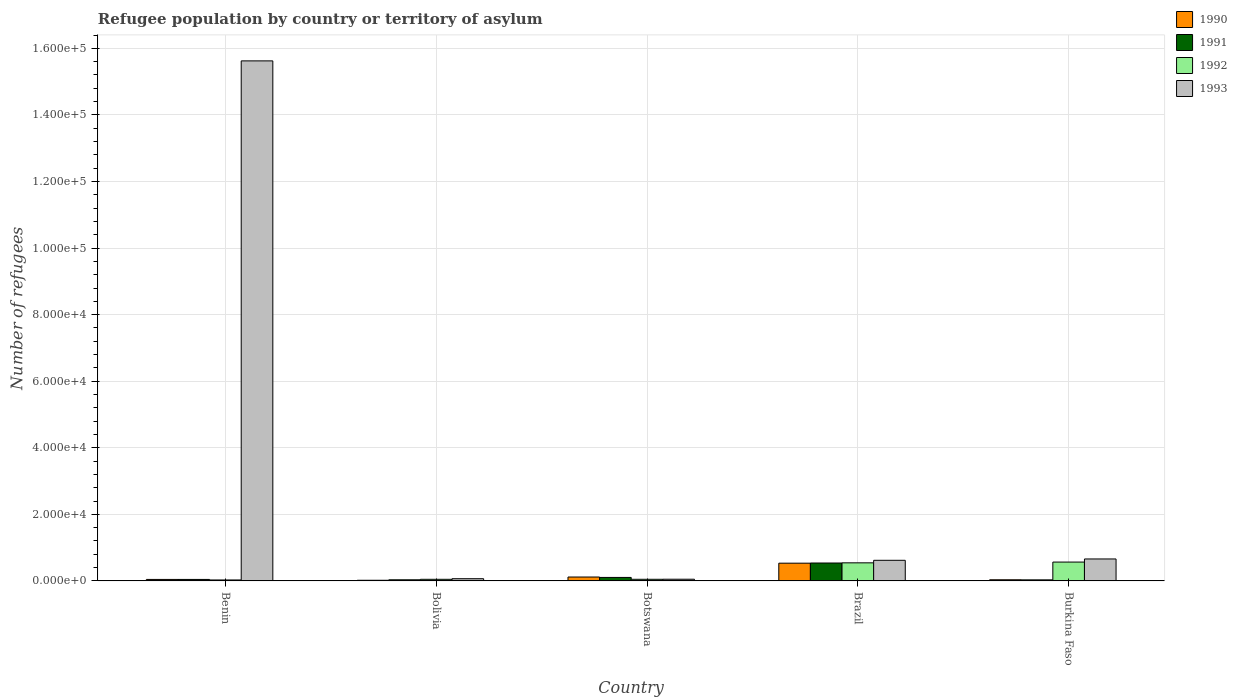How many bars are there on the 4th tick from the left?
Give a very brief answer. 4. How many bars are there on the 3rd tick from the right?
Offer a very short reply. 4. What is the label of the 4th group of bars from the left?
Ensure brevity in your answer.  Brazil. What is the number of refugees in 1992 in Bolivia?
Provide a short and direct response. 491. Across all countries, what is the maximum number of refugees in 1992?
Keep it short and to the point. 5670. In which country was the number of refugees in 1993 maximum?
Your response must be concise. Benin. What is the total number of refugees in 1991 in the graph?
Provide a succinct answer. 7560. What is the difference between the number of refugees in 1992 in Bolivia and that in Burkina Faso?
Your answer should be compact. -5179. What is the difference between the number of refugees in 1993 in Burkina Faso and the number of refugees in 1991 in Brazil?
Ensure brevity in your answer.  1215. What is the average number of refugees in 1990 per country?
Keep it short and to the point. 1504. What is the difference between the number of refugees of/in 1990 and number of refugees of/in 1992 in Botswana?
Offer a terse response. 682. In how many countries, is the number of refugees in 1993 greater than 104000?
Offer a terse response. 1. What is the ratio of the number of refugees in 1992 in Bolivia to that in Burkina Faso?
Provide a succinct answer. 0.09. Is the difference between the number of refugees in 1990 in Benin and Brazil greater than the difference between the number of refugees in 1992 in Benin and Brazil?
Offer a very short reply. Yes. What is the difference between the highest and the second highest number of refugees in 1991?
Ensure brevity in your answer.  -4933. What is the difference between the highest and the lowest number of refugees in 1992?
Give a very brief answer. 5377. In how many countries, is the number of refugees in 1993 greater than the average number of refugees in 1993 taken over all countries?
Ensure brevity in your answer.  1. Is the sum of the number of refugees in 1991 in Benin and Brazil greater than the maximum number of refugees in 1992 across all countries?
Offer a very short reply. Yes. Is it the case that in every country, the sum of the number of refugees in 1993 and number of refugees in 1992 is greater than the sum of number of refugees in 1990 and number of refugees in 1991?
Offer a terse response. No. What does the 2nd bar from the left in Botswana represents?
Give a very brief answer. 1991. Is it the case that in every country, the sum of the number of refugees in 1991 and number of refugees in 1992 is greater than the number of refugees in 1993?
Your answer should be compact. No. How many bars are there?
Give a very brief answer. 20. Are all the bars in the graph horizontal?
Make the answer very short. No. What is the difference between two consecutive major ticks on the Y-axis?
Your answer should be compact. 2.00e+04. Does the graph contain grids?
Ensure brevity in your answer.  Yes. Where does the legend appear in the graph?
Your answer should be compact. Top right. How are the legend labels stacked?
Your answer should be compact. Vertical. What is the title of the graph?
Ensure brevity in your answer.  Refugee population by country or territory of asylum. What is the label or title of the Y-axis?
Provide a succinct answer. Number of refugees. What is the Number of refugees of 1990 in Benin?
Your answer should be very brief. 456. What is the Number of refugees in 1991 in Benin?
Keep it short and to the point. 456. What is the Number of refugees in 1992 in Benin?
Make the answer very short. 293. What is the Number of refugees of 1993 in Benin?
Make the answer very short. 1.56e+05. What is the Number of refugees of 1990 in Bolivia?
Make the answer very short. 200. What is the Number of refugees in 1991 in Bolivia?
Your answer should be very brief. 341. What is the Number of refugees in 1992 in Bolivia?
Keep it short and to the point. 491. What is the Number of refugees of 1993 in Bolivia?
Your answer should be very brief. 669. What is the Number of refugees in 1990 in Botswana?
Offer a terse response. 1179. What is the Number of refugees of 1991 in Botswana?
Offer a very short reply. 1054. What is the Number of refugees in 1992 in Botswana?
Your answer should be compact. 497. What is the Number of refugees in 1993 in Botswana?
Your answer should be compact. 514. What is the Number of refugees in 1990 in Brazil?
Offer a very short reply. 5335. What is the Number of refugees of 1991 in Brazil?
Provide a short and direct response. 5389. What is the Number of refugees in 1992 in Brazil?
Your answer should be compact. 5439. What is the Number of refugees of 1993 in Brazil?
Your answer should be very brief. 6198. What is the Number of refugees of 1990 in Burkina Faso?
Give a very brief answer. 350. What is the Number of refugees of 1991 in Burkina Faso?
Give a very brief answer. 320. What is the Number of refugees in 1992 in Burkina Faso?
Your response must be concise. 5670. What is the Number of refugees of 1993 in Burkina Faso?
Your answer should be compact. 6604. Across all countries, what is the maximum Number of refugees in 1990?
Your answer should be very brief. 5335. Across all countries, what is the maximum Number of refugees of 1991?
Your answer should be very brief. 5389. Across all countries, what is the maximum Number of refugees of 1992?
Offer a terse response. 5670. Across all countries, what is the maximum Number of refugees of 1993?
Your response must be concise. 1.56e+05. Across all countries, what is the minimum Number of refugees in 1991?
Your answer should be very brief. 320. Across all countries, what is the minimum Number of refugees in 1992?
Make the answer very short. 293. Across all countries, what is the minimum Number of refugees of 1993?
Give a very brief answer. 514. What is the total Number of refugees of 1990 in the graph?
Give a very brief answer. 7520. What is the total Number of refugees of 1991 in the graph?
Your response must be concise. 7560. What is the total Number of refugees in 1992 in the graph?
Offer a very short reply. 1.24e+04. What is the total Number of refugees of 1993 in the graph?
Give a very brief answer. 1.70e+05. What is the difference between the Number of refugees of 1990 in Benin and that in Bolivia?
Your answer should be very brief. 256. What is the difference between the Number of refugees of 1991 in Benin and that in Bolivia?
Offer a very short reply. 115. What is the difference between the Number of refugees in 1992 in Benin and that in Bolivia?
Your answer should be very brief. -198. What is the difference between the Number of refugees of 1993 in Benin and that in Bolivia?
Ensure brevity in your answer.  1.56e+05. What is the difference between the Number of refugees of 1990 in Benin and that in Botswana?
Your response must be concise. -723. What is the difference between the Number of refugees of 1991 in Benin and that in Botswana?
Your answer should be very brief. -598. What is the difference between the Number of refugees in 1992 in Benin and that in Botswana?
Keep it short and to the point. -204. What is the difference between the Number of refugees in 1993 in Benin and that in Botswana?
Keep it short and to the point. 1.56e+05. What is the difference between the Number of refugees of 1990 in Benin and that in Brazil?
Your answer should be very brief. -4879. What is the difference between the Number of refugees of 1991 in Benin and that in Brazil?
Make the answer very short. -4933. What is the difference between the Number of refugees in 1992 in Benin and that in Brazil?
Provide a short and direct response. -5146. What is the difference between the Number of refugees of 1993 in Benin and that in Brazil?
Your answer should be compact. 1.50e+05. What is the difference between the Number of refugees in 1990 in Benin and that in Burkina Faso?
Provide a short and direct response. 106. What is the difference between the Number of refugees of 1991 in Benin and that in Burkina Faso?
Your response must be concise. 136. What is the difference between the Number of refugees of 1992 in Benin and that in Burkina Faso?
Ensure brevity in your answer.  -5377. What is the difference between the Number of refugees of 1993 in Benin and that in Burkina Faso?
Your response must be concise. 1.50e+05. What is the difference between the Number of refugees of 1990 in Bolivia and that in Botswana?
Keep it short and to the point. -979. What is the difference between the Number of refugees of 1991 in Bolivia and that in Botswana?
Your answer should be compact. -713. What is the difference between the Number of refugees in 1992 in Bolivia and that in Botswana?
Make the answer very short. -6. What is the difference between the Number of refugees of 1993 in Bolivia and that in Botswana?
Offer a very short reply. 155. What is the difference between the Number of refugees in 1990 in Bolivia and that in Brazil?
Offer a very short reply. -5135. What is the difference between the Number of refugees of 1991 in Bolivia and that in Brazil?
Ensure brevity in your answer.  -5048. What is the difference between the Number of refugees of 1992 in Bolivia and that in Brazil?
Your response must be concise. -4948. What is the difference between the Number of refugees of 1993 in Bolivia and that in Brazil?
Offer a terse response. -5529. What is the difference between the Number of refugees of 1990 in Bolivia and that in Burkina Faso?
Give a very brief answer. -150. What is the difference between the Number of refugees in 1991 in Bolivia and that in Burkina Faso?
Keep it short and to the point. 21. What is the difference between the Number of refugees of 1992 in Bolivia and that in Burkina Faso?
Your answer should be compact. -5179. What is the difference between the Number of refugees of 1993 in Bolivia and that in Burkina Faso?
Offer a very short reply. -5935. What is the difference between the Number of refugees in 1990 in Botswana and that in Brazil?
Keep it short and to the point. -4156. What is the difference between the Number of refugees of 1991 in Botswana and that in Brazil?
Your answer should be compact. -4335. What is the difference between the Number of refugees of 1992 in Botswana and that in Brazil?
Offer a very short reply. -4942. What is the difference between the Number of refugees in 1993 in Botswana and that in Brazil?
Your answer should be very brief. -5684. What is the difference between the Number of refugees of 1990 in Botswana and that in Burkina Faso?
Make the answer very short. 829. What is the difference between the Number of refugees of 1991 in Botswana and that in Burkina Faso?
Ensure brevity in your answer.  734. What is the difference between the Number of refugees in 1992 in Botswana and that in Burkina Faso?
Ensure brevity in your answer.  -5173. What is the difference between the Number of refugees of 1993 in Botswana and that in Burkina Faso?
Make the answer very short. -6090. What is the difference between the Number of refugees of 1990 in Brazil and that in Burkina Faso?
Provide a short and direct response. 4985. What is the difference between the Number of refugees in 1991 in Brazil and that in Burkina Faso?
Keep it short and to the point. 5069. What is the difference between the Number of refugees in 1992 in Brazil and that in Burkina Faso?
Keep it short and to the point. -231. What is the difference between the Number of refugees of 1993 in Brazil and that in Burkina Faso?
Make the answer very short. -406. What is the difference between the Number of refugees in 1990 in Benin and the Number of refugees in 1991 in Bolivia?
Your response must be concise. 115. What is the difference between the Number of refugees of 1990 in Benin and the Number of refugees of 1992 in Bolivia?
Keep it short and to the point. -35. What is the difference between the Number of refugees of 1990 in Benin and the Number of refugees of 1993 in Bolivia?
Offer a very short reply. -213. What is the difference between the Number of refugees of 1991 in Benin and the Number of refugees of 1992 in Bolivia?
Your answer should be compact. -35. What is the difference between the Number of refugees of 1991 in Benin and the Number of refugees of 1993 in Bolivia?
Offer a terse response. -213. What is the difference between the Number of refugees in 1992 in Benin and the Number of refugees in 1993 in Bolivia?
Ensure brevity in your answer.  -376. What is the difference between the Number of refugees in 1990 in Benin and the Number of refugees in 1991 in Botswana?
Ensure brevity in your answer.  -598. What is the difference between the Number of refugees of 1990 in Benin and the Number of refugees of 1992 in Botswana?
Your answer should be compact. -41. What is the difference between the Number of refugees of 1990 in Benin and the Number of refugees of 1993 in Botswana?
Offer a terse response. -58. What is the difference between the Number of refugees in 1991 in Benin and the Number of refugees in 1992 in Botswana?
Offer a terse response. -41. What is the difference between the Number of refugees in 1991 in Benin and the Number of refugees in 1993 in Botswana?
Make the answer very short. -58. What is the difference between the Number of refugees of 1992 in Benin and the Number of refugees of 1993 in Botswana?
Provide a succinct answer. -221. What is the difference between the Number of refugees in 1990 in Benin and the Number of refugees in 1991 in Brazil?
Offer a terse response. -4933. What is the difference between the Number of refugees in 1990 in Benin and the Number of refugees in 1992 in Brazil?
Offer a very short reply. -4983. What is the difference between the Number of refugees in 1990 in Benin and the Number of refugees in 1993 in Brazil?
Your answer should be compact. -5742. What is the difference between the Number of refugees in 1991 in Benin and the Number of refugees in 1992 in Brazil?
Keep it short and to the point. -4983. What is the difference between the Number of refugees in 1991 in Benin and the Number of refugees in 1993 in Brazil?
Ensure brevity in your answer.  -5742. What is the difference between the Number of refugees of 1992 in Benin and the Number of refugees of 1993 in Brazil?
Keep it short and to the point. -5905. What is the difference between the Number of refugees of 1990 in Benin and the Number of refugees of 1991 in Burkina Faso?
Give a very brief answer. 136. What is the difference between the Number of refugees in 1990 in Benin and the Number of refugees in 1992 in Burkina Faso?
Provide a short and direct response. -5214. What is the difference between the Number of refugees of 1990 in Benin and the Number of refugees of 1993 in Burkina Faso?
Provide a short and direct response. -6148. What is the difference between the Number of refugees in 1991 in Benin and the Number of refugees in 1992 in Burkina Faso?
Provide a short and direct response. -5214. What is the difference between the Number of refugees in 1991 in Benin and the Number of refugees in 1993 in Burkina Faso?
Provide a short and direct response. -6148. What is the difference between the Number of refugees of 1992 in Benin and the Number of refugees of 1993 in Burkina Faso?
Make the answer very short. -6311. What is the difference between the Number of refugees of 1990 in Bolivia and the Number of refugees of 1991 in Botswana?
Provide a succinct answer. -854. What is the difference between the Number of refugees of 1990 in Bolivia and the Number of refugees of 1992 in Botswana?
Ensure brevity in your answer.  -297. What is the difference between the Number of refugees in 1990 in Bolivia and the Number of refugees in 1993 in Botswana?
Offer a terse response. -314. What is the difference between the Number of refugees of 1991 in Bolivia and the Number of refugees of 1992 in Botswana?
Ensure brevity in your answer.  -156. What is the difference between the Number of refugees of 1991 in Bolivia and the Number of refugees of 1993 in Botswana?
Your answer should be very brief. -173. What is the difference between the Number of refugees of 1992 in Bolivia and the Number of refugees of 1993 in Botswana?
Provide a succinct answer. -23. What is the difference between the Number of refugees in 1990 in Bolivia and the Number of refugees in 1991 in Brazil?
Provide a succinct answer. -5189. What is the difference between the Number of refugees in 1990 in Bolivia and the Number of refugees in 1992 in Brazil?
Your answer should be very brief. -5239. What is the difference between the Number of refugees of 1990 in Bolivia and the Number of refugees of 1993 in Brazil?
Provide a succinct answer. -5998. What is the difference between the Number of refugees in 1991 in Bolivia and the Number of refugees in 1992 in Brazil?
Give a very brief answer. -5098. What is the difference between the Number of refugees of 1991 in Bolivia and the Number of refugees of 1993 in Brazil?
Your answer should be compact. -5857. What is the difference between the Number of refugees in 1992 in Bolivia and the Number of refugees in 1993 in Brazil?
Provide a succinct answer. -5707. What is the difference between the Number of refugees of 1990 in Bolivia and the Number of refugees of 1991 in Burkina Faso?
Provide a short and direct response. -120. What is the difference between the Number of refugees of 1990 in Bolivia and the Number of refugees of 1992 in Burkina Faso?
Keep it short and to the point. -5470. What is the difference between the Number of refugees of 1990 in Bolivia and the Number of refugees of 1993 in Burkina Faso?
Give a very brief answer. -6404. What is the difference between the Number of refugees of 1991 in Bolivia and the Number of refugees of 1992 in Burkina Faso?
Make the answer very short. -5329. What is the difference between the Number of refugees in 1991 in Bolivia and the Number of refugees in 1993 in Burkina Faso?
Your response must be concise. -6263. What is the difference between the Number of refugees in 1992 in Bolivia and the Number of refugees in 1993 in Burkina Faso?
Give a very brief answer. -6113. What is the difference between the Number of refugees in 1990 in Botswana and the Number of refugees in 1991 in Brazil?
Ensure brevity in your answer.  -4210. What is the difference between the Number of refugees in 1990 in Botswana and the Number of refugees in 1992 in Brazil?
Give a very brief answer. -4260. What is the difference between the Number of refugees of 1990 in Botswana and the Number of refugees of 1993 in Brazil?
Make the answer very short. -5019. What is the difference between the Number of refugees in 1991 in Botswana and the Number of refugees in 1992 in Brazil?
Give a very brief answer. -4385. What is the difference between the Number of refugees of 1991 in Botswana and the Number of refugees of 1993 in Brazil?
Give a very brief answer. -5144. What is the difference between the Number of refugees in 1992 in Botswana and the Number of refugees in 1993 in Brazil?
Provide a short and direct response. -5701. What is the difference between the Number of refugees in 1990 in Botswana and the Number of refugees in 1991 in Burkina Faso?
Give a very brief answer. 859. What is the difference between the Number of refugees of 1990 in Botswana and the Number of refugees of 1992 in Burkina Faso?
Offer a very short reply. -4491. What is the difference between the Number of refugees of 1990 in Botswana and the Number of refugees of 1993 in Burkina Faso?
Provide a succinct answer. -5425. What is the difference between the Number of refugees of 1991 in Botswana and the Number of refugees of 1992 in Burkina Faso?
Your answer should be very brief. -4616. What is the difference between the Number of refugees in 1991 in Botswana and the Number of refugees in 1993 in Burkina Faso?
Make the answer very short. -5550. What is the difference between the Number of refugees of 1992 in Botswana and the Number of refugees of 1993 in Burkina Faso?
Provide a short and direct response. -6107. What is the difference between the Number of refugees of 1990 in Brazil and the Number of refugees of 1991 in Burkina Faso?
Your answer should be very brief. 5015. What is the difference between the Number of refugees in 1990 in Brazil and the Number of refugees in 1992 in Burkina Faso?
Your answer should be very brief. -335. What is the difference between the Number of refugees of 1990 in Brazil and the Number of refugees of 1993 in Burkina Faso?
Your response must be concise. -1269. What is the difference between the Number of refugees of 1991 in Brazil and the Number of refugees of 1992 in Burkina Faso?
Give a very brief answer. -281. What is the difference between the Number of refugees in 1991 in Brazil and the Number of refugees in 1993 in Burkina Faso?
Ensure brevity in your answer.  -1215. What is the difference between the Number of refugees in 1992 in Brazil and the Number of refugees in 1993 in Burkina Faso?
Make the answer very short. -1165. What is the average Number of refugees in 1990 per country?
Keep it short and to the point. 1504. What is the average Number of refugees in 1991 per country?
Provide a succinct answer. 1512. What is the average Number of refugees in 1992 per country?
Your answer should be very brief. 2478. What is the average Number of refugees of 1993 per country?
Ensure brevity in your answer.  3.40e+04. What is the difference between the Number of refugees in 1990 and Number of refugees in 1992 in Benin?
Your answer should be compact. 163. What is the difference between the Number of refugees in 1990 and Number of refugees in 1993 in Benin?
Your response must be concise. -1.56e+05. What is the difference between the Number of refugees of 1991 and Number of refugees of 1992 in Benin?
Provide a short and direct response. 163. What is the difference between the Number of refugees of 1991 and Number of refugees of 1993 in Benin?
Offer a terse response. -1.56e+05. What is the difference between the Number of refugees in 1992 and Number of refugees in 1993 in Benin?
Offer a very short reply. -1.56e+05. What is the difference between the Number of refugees in 1990 and Number of refugees in 1991 in Bolivia?
Provide a short and direct response. -141. What is the difference between the Number of refugees in 1990 and Number of refugees in 1992 in Bolivia?
Your response must be concise. -291. What is the difference between the Number of refugees of 1990 and Number of refugees of 1993 in Bolivia?
Provide a short and direct response. -469. What is the difference between the Number of refugees in 1991 and Number of refugees in 1992 in Bolivia?
Ensure brevity in your answer.  -150. What is the difference between the Number of refugees of 1991 and Number of refugees of 1993 in Bolivia?
Your answer should be compact. -328. What is the difference between the Number of refugees in 1992 and Number of refugees in 1993 in Bolivia?
Provide a short and direct response. -178. What is the difference between the Number of refugees of 1990 and Number of refugees of 1991 in Botswana?
Offer a terse response. 125. What is the difference between the Number of refugees in 1990 and Number of refugees in 1992 in Botswana?
Provide a short and direct response. 682. What is the difference between the Number of refugees of 1990 and Number of refugees of 1993 in Botswana?
Give a very brief answer. 665. What is the difference between the Number of refugees of 1991 and Number of refugees of 1992 in Botswana?
Offer a very short reply. 557. What is the difference between the Number of refugees of 1991 and Number of refugees of 1993 in Botswana?
Offer a very short reply. 540. What is the difference between the Number of refugees in 1990 and Number of refugees in 1991 in Brazil?
Provide a short and direct response. -54. What is the difference between the Number of refugees of 1990 and Number of refugees of 1992 in Brazil?
Provide a short and direct response. -104. What is the difference between the Number of refugees in 1990 and Number of refugees in 1993 in Brazil?
Your answer should be compact. -863. What is the difference between the Number of refugees in 1991 and Number of refugees in 1992 in Brazil?
Provide a short and direct response. -50. What is the difference between the Number of refugees of 1991 and Number of refugees of 1993 in Brazil?
Your answer should be very brief. -809. What is the difference between the Number of refugees of 1992 and Number of refugees of 1993 in Brazil?
Your answer should be very brief. -759. What is the difference between the Number of refugees in 1990 and Number of refugees in 1991 in Burkina Faso?
Offer a terse response. 30. What is the difference between the Number of refugees of 1990 and Number of refugees of 1992 in Burkina Faso?
Provide a short and direct response. -5320. What is the difference between the Number of refugees in 1990 and Number of refugees in 1993 in Burkina Faso?
Provide a succinct answer. -6254. What is the difference between the Number of refugees in 1991 and Number of refugees in 1992 in Burkina Faso?
Provide a short and direct response. -5350. What is the difference between the Number of refugees in 1991 and Number of refugees in 1993 in Burkina Faso?
Offer a terse response. -6284. What is the difference between the Number of refugees of 1992 and Number of refugees of 1993 in Burkina Faso?
Offer a very short reply. -934. What is the ratio of the Number of refugees in 1990 in Benin to that in Bolivia?
Provide a short and direct response. 2.28. What is the ratio of the Number of refugees of 1991 in Benin to that in Bolivia?
Give a very brief answer. 1.34. What is the ratio of the Number of refugees of 1992 in Benin to that in Bolivia?
Give a very brief answer. 0.6. What is the ratio of the Number of refugees in 1993 in Benin to that in Bolivia?
Your response must be concise. 233.54. What is the ratio of the Number of refugees of 1990 in Benin to that in Botswana?
Offer a terse response. 0.39. What is the ratio of the Number of refugees of 1991 in Benin to that in Botswana?
Provide a succinct answer. 0.43. What is the ratio of the Number of refugees in 1992 in Benin to that in Botswana?
Provide a succinct answer. 0.59. What is the ratio of the Number of refugees of 1993 in Benin to that in Botswana?
Give a very brief answer. 303.97. What is the ratio of the Number of refugees of 1990 in Benin to that in Brazil?
Make the answer very short. 0.09. What is the ratio of the Number of refugees of 1991 in Benin to that in Brazil?
Keep it short and to the point. 0.08. What is the ratio of the Number of refugees of 1992 in Benin to that in Brazil?
Provide a short and direct response. 0.05. What is the ratio of the Number of refugees in 1993 in Benin to that in Brazil?
Your answer should be compact. 25.21. What is the ratio of the Number of refugees in 1990 in Benin to that in Burkina Faso?
Offer a very short reply. 1.3. What is the ratio of the Number of refugees in 1991 in Benin to that in Burkina Faso?
Give a very brief answer. 1.43. What is the ratio of the Number of refugees of 1992 in Benin to that in Burkina Faso?
Give a very brief answer. 0.05. What is the ratio of the Number of refugees in 1993 in Benin to that in Burkina Faso?
Your answer should be compact. 23.66. What is the ratio of the Number of refugees in 1990 in Bolivia to that in Botswana?
Ensure brevity in your answer.  0.17. What is the ratio of the Number of refugees of 1991 in Bolivia to that in Botswana?
Your response must be concise. 0.32. What is the ratio of the Number of refugees in 1992 in Bolivia to that in Botswana?
Offer a very short reply. 0.99. What is the ratio of the Number of refugees of 1993 in Bolivia to that in Botswana?
Make the answer very short. 1.3. What is the ratio of the Number of refugees in 1990 in Bolivia to that in Brazil?
Your response must be concise. 0.04. What is the ratio of the Number of refugees of 1991 in Bolivia to that in Brazil?
Offer a terse response. 0.06. What is the ratio of the Number of refugees in 1992 in Bolivia to that in Brazil?
Offer a very short reply. 0.09. What is the ratio of the Number of refugees of 1993 in Bolivia to that in Brazil?
Your answer should be compact. 0.11. What is the ratio of the Number of refugees of 1991 in Bolivia to that in Burkina Faso?
Your response must be concise. 1.07. What is the ratio of the Number of refugees of 1992 in Bolivia to that in Burkina Faso?
Provide a short and direct response. 0.09. What is the ratio of the Number of refugees in 1993 in Bolivia to that in Burkina Faso?
Your answer should be very brief. 0.1. What is the ratio of the Number of refugees of 1990 in Botswana to that in Brazil?
Provide a short and direct response. 0.22. What is the ratio of the Number of refugees in 1991 in Botswana to that in Brazil?
Offer a terse response. 0.2. What is the ratio of the Number of refugees of 1992 in Botswana to that in Brazil?
Offer a very short reply. 0.09. What is the ratio of the Number of refugees in 1993 in Botswana to that in Brazil?
Your response must be concise. 0.08. What is the ratio of the Number of refugees in 1990 in Botswana to that in Burkina Faso?
Give a very brief answer. 3.37. What is the ratio of the Number of refugees of 1991 in Botswana to that in Burkina Faso?
Your response must be concise. 3.29. What is the ratio of the Number of refugees in 1992 in Botswana to that in Burkina Faso?
Provide a succinct answer. 0.09. What is the ratio of the Number of refugees in 1993 in Botswana to that in Burkina Faso?
Keep it short and to the point. 0.08. What is the ratio of the Number of refugees of 1990 in Brazil to that in Burkina Faso?
Offer a very short reply. 15.24. What is the ratio of the Number of refugees of 1991 in Brazil to that in Burkina Faso?
Provide a short and direct response. 16.84. What is the ratio of the Number of refugees of 1992 in Brazil to that in Burkina Faso?
Provide a short and direct response. 0.96. What is the ratio of the Number of refugees of 1993 in Brazil to that in Burkina Faso?
Offer a very short reply. 0.94. What is the difference between the highest and the second highest Number of refugees in 1990?
Your response must be concise. 4156. What is the difference between the highest and the second highest Number of refugees in 1991?
Provide a short and direct response. 4335. What is the difference between the highest and the second highest Number of refugees of 1992?
Your answer should be very brief. 231. What is the difference between the highest and the second highest Number of refugees in 1993?
Your answer should be very brief. 1.50e+05. What is the difference between the highest and the lowest Number of refugees in 1990?
Provide a short and direct response. 5135. What is the difference between the highest and the lowest Number of refugees of 1991?
Make the answer very short. 5069. What is the difference between the highest and the lowest Number of refugees in 1992?
Offer a very short reply. 5377. What is the difference between the highest and the lowest Number of refugees of 1993?
Ensure brevity in your answer.  1.56e+05. 